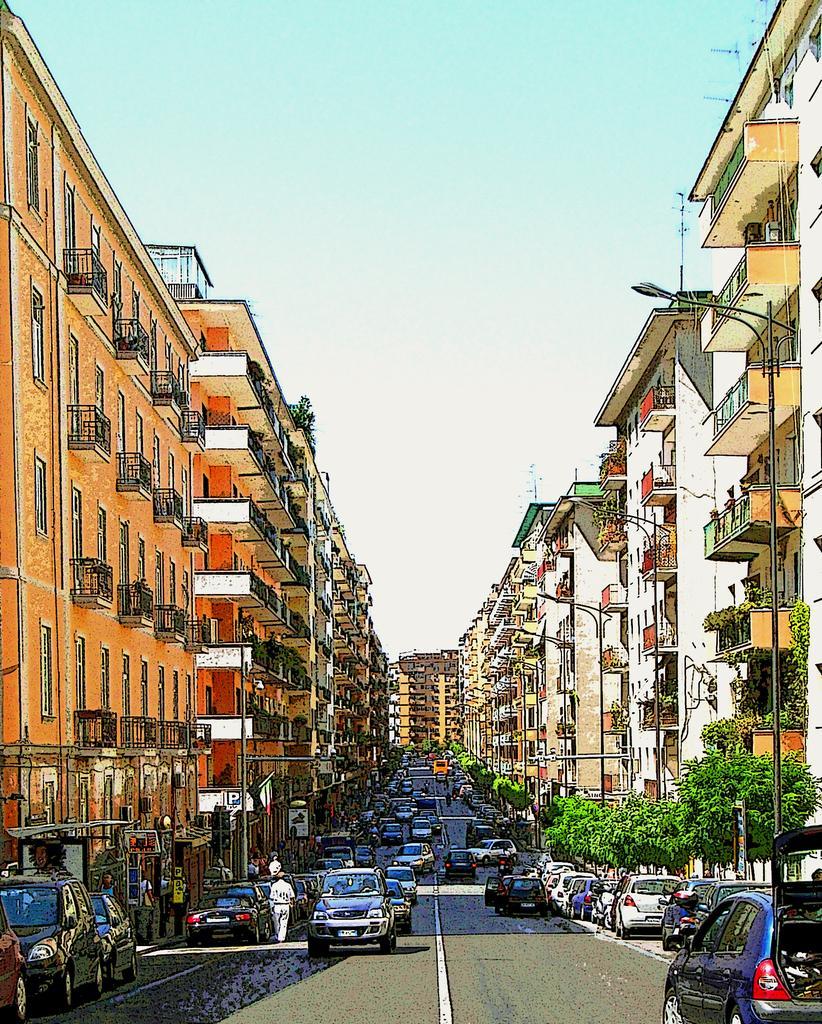How would you summarize this image in a sentence or two? In this picture we can see some people and vehicles on the path. On the right side of the vehicles there are trees, buildings and poles with lights. Behind the buildings there is the sky. 